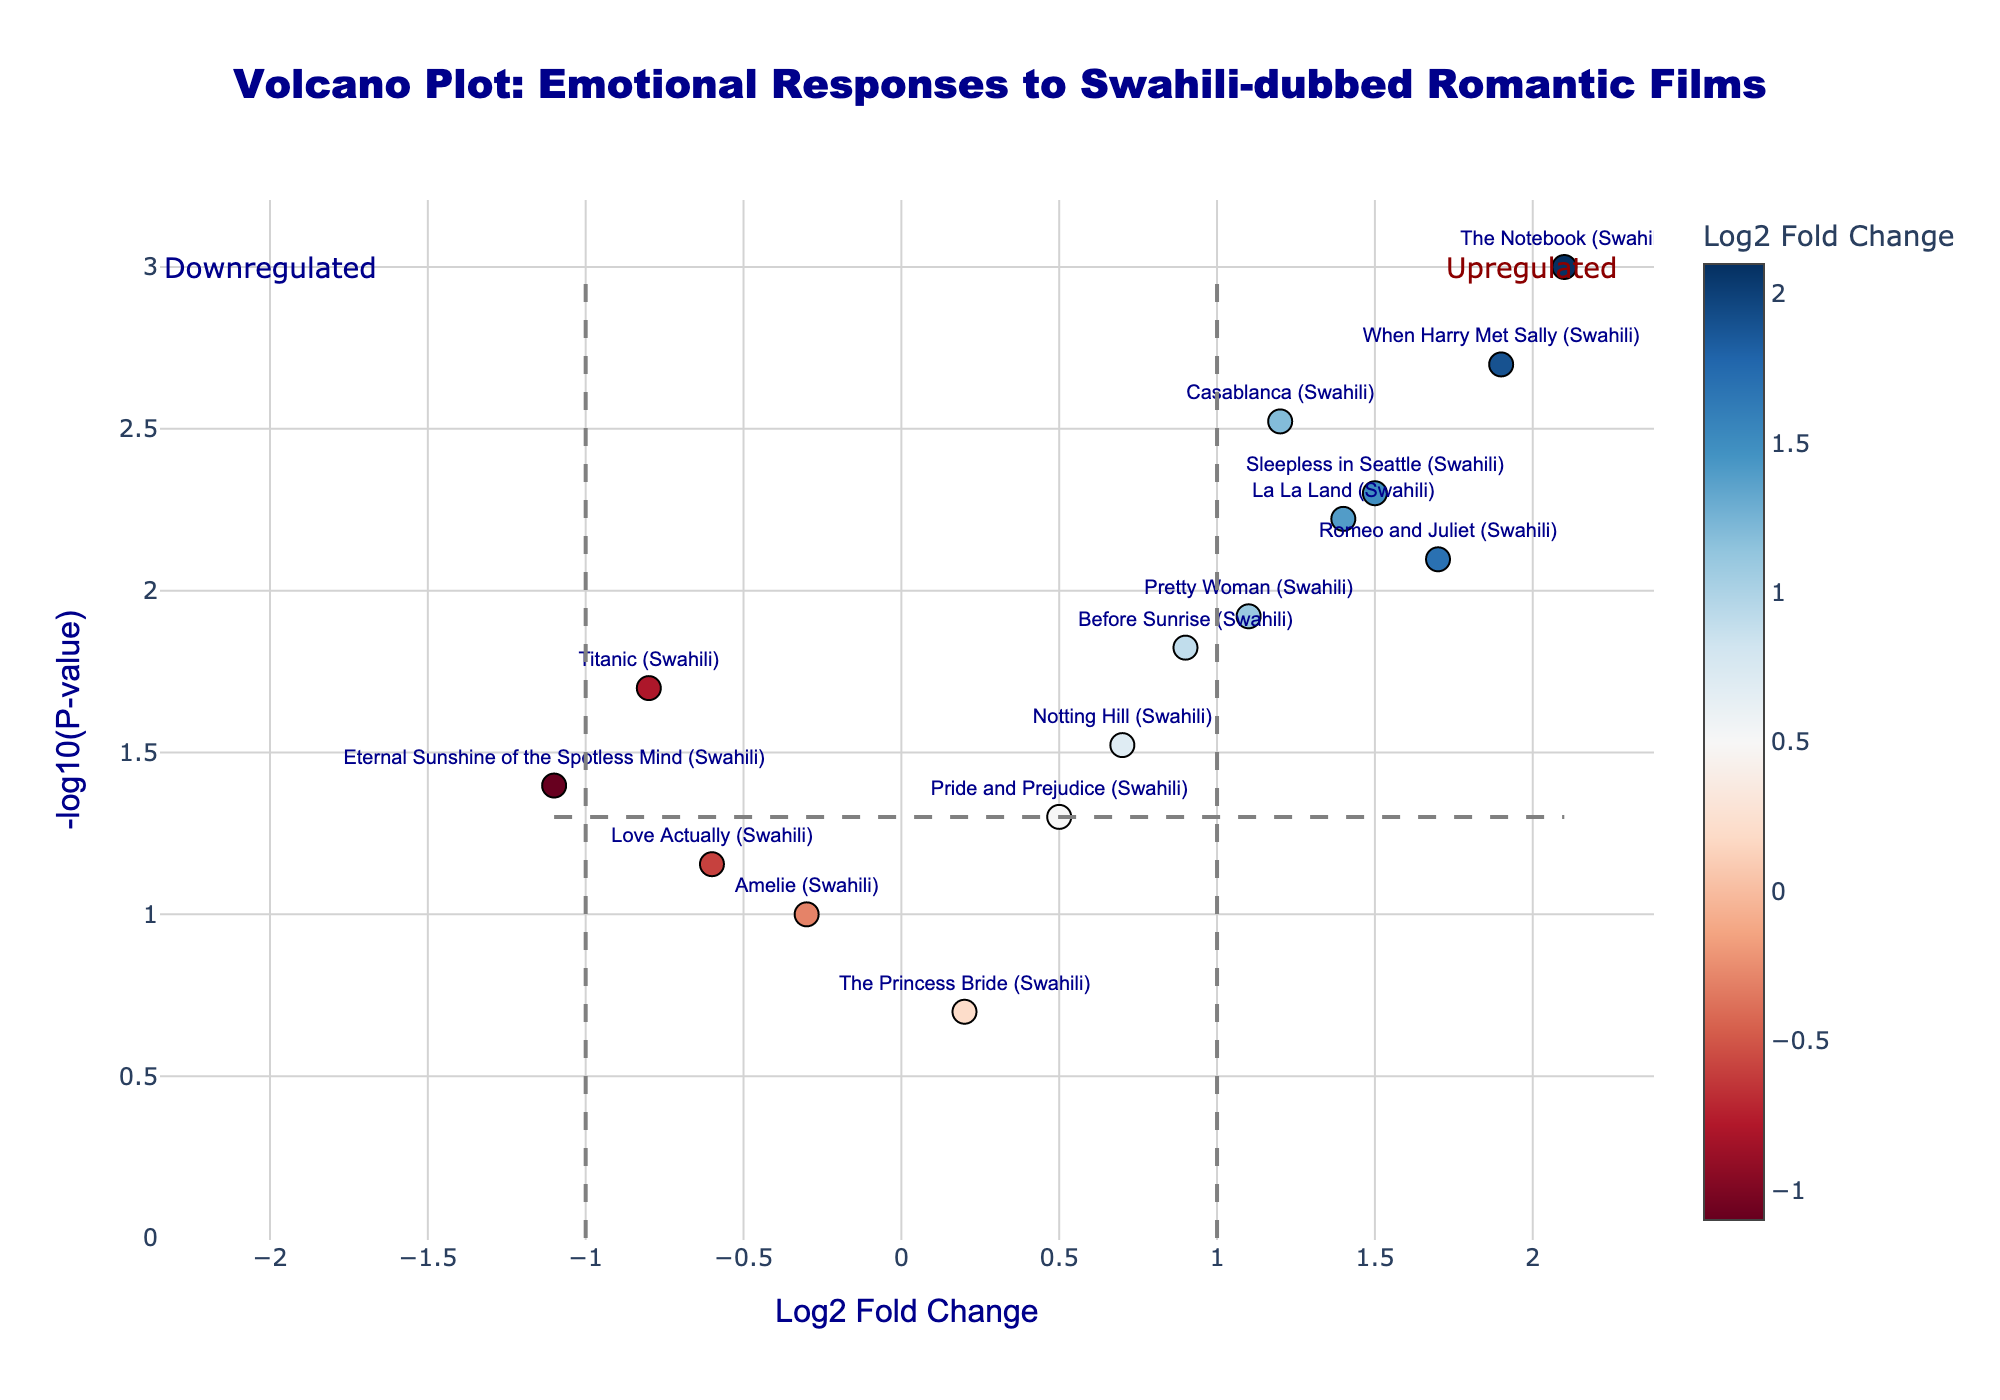What is the title of the figure? The title of the figure appears at the top and summarizes the main focus of the plot. By reading, we can see it is about emotional responses to Swahili-dubbed romantic films as compared to their original versions.
Answer: Volcano Plot: Emotional Responses to Swahili-dubbed Romantic Films Which axis represents the Log2 Fold Change? The x-axis is labeled with "Log2 Fold Change," indicating that this axis represents the Log2 Fold Change values for the emotional responses.
Answer: x-axis What does a point to the right of the vertical dashed line at Log2 Fold Change = 1 mean? Points to the right of the vertical dashed line at Log2 Fold Change = 1 indicate films where the emotional response to the Swahili-dubbed version is significantly higher (upregulated) compared to the original language version.
Answer: Upregulated emotional response Which film has the highest -log10(P-value)? The highest -log10(P-value) indicates the most statistically significant difference. By visually identifying the highest point on the y-axis, we find that "The Notebook (Swahili)" is this film.
Answer: The Notebook (Swahili) How many films have a statistically significant increased emotional response (p-value < 0.05 and Log2 Fold Change > 1)? For a statistically significant increased response, a point must have a p-value < 0.05 (-log10(p-value) > 1.3) and Log2 Fold Change > 1. Counting the points in the top right quadrant of the plot gives us the films: Casablanca (Swahili), The Notebook (Swahili), Romeo and Juliet (Swahili), La La Land (Swahili), When Harry Met Sally (Swahili), Sleepless in Seattle (Swahili), and Pretty Woman (Swahili).
Answer: 7 Which film has the most negative Log2 Fold Change? The most negative Log2 Fold Change will be the point furthest to the left on the x-axis. This corresponds to "Eternal Sunshine of the Spotless Mind (Swahili)."
Answer: Eternal Sunshine of the Spotless Mind (Swahili) Compare the emotional responses of "Titanic (Swahili)" and "Before Sunrise (Swahili)." Which film has a more significant change? "Titanic (Swahili)" has a Log2 Fold Change of -0.8 and a p-value of 0.02 (-log10(p-value) ≈ 1.7), while "Before Sunrise (Swahili)" has a Log2 Fold Change of 0.9 and a p-value of 0.015 (-log10(p-value) ≈ 1.82). "Before Sunrise (Swahili)" has a slightly higher -log10(p-value), indicating a more statistically significant change.
Answer: Before Sunrise (Swahili) What does a point in the top left quadrant represent? The top left quadrant includes points with high -log10(p-value) and negative Log2 Fold Change, indicating Swahili-dubbed films with significantly lower emotional responses compared to the original versions.
Answer: Downregulated emotional response 